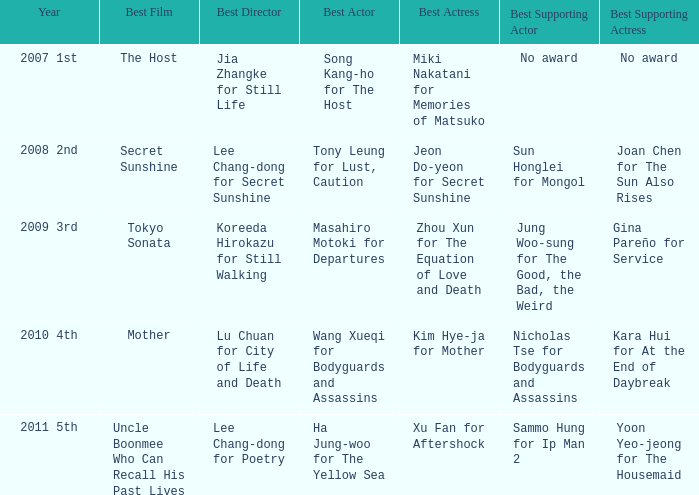Name the best actor for uncle boonmee who can recall his past lives Ha Jung-woo for The Yellow Sea. Could you parse the entire table as a dict? {'header': ['Year', 'Best Film', 'Best Director', 'Best Actor', 'Best Actress', 'Best Supporting Actor', 'Best Supporting Actress'], 'rows': [['2007 1st', 'The Host', 'Jia Zhangke for Still Life', 'Song Kang-ho for The Host', 'Miki Nakatani for Memories of Matsuko', 'No award', 'No award'], ['2008 2nd', 'Secret Sunshine', 'Lee Chang-dong for Secret Sunshine', 'Tony Leung for Lust, Caution', 'Jeon Do-yeon for Secret Sunshine', 'Sun Honglei for Mongol', 'Joan Chen for The Sun Also Rises'], ['2009 3rd', 'Tokyo Sonata', 'Koreeda Hirokazu for Still Walking', 'Masahiro Motoki for Departures', 'Zhou Xun for The Equation of Love and Death', 'Jung Woo-sung for The Good, the Bad, the Weird', 'Gina Pareño for Service'], ['2010 4th', 'Mother', 'Lu Chuan for City of Life and Death', 'Wang Xueqi for Bodyguards and Assassins', 'Kim Hye-ja for Mother', 'Nicholas Tse for Bodyguards and Assassins', 'Kara Hui for At the End of Daybreak'], ['2011 5th', 'Uncle Boonmee Who Can Recall His Past Lives', 'Lee Chang-dong for Poetry', 'Ha Jung-woo for The Yellow Sea', 'Xu Fan for Aftershock', 'Sammo Hung for Ip Man 2', 'Yoon Yeo-jeong for The Housemaid']]} 